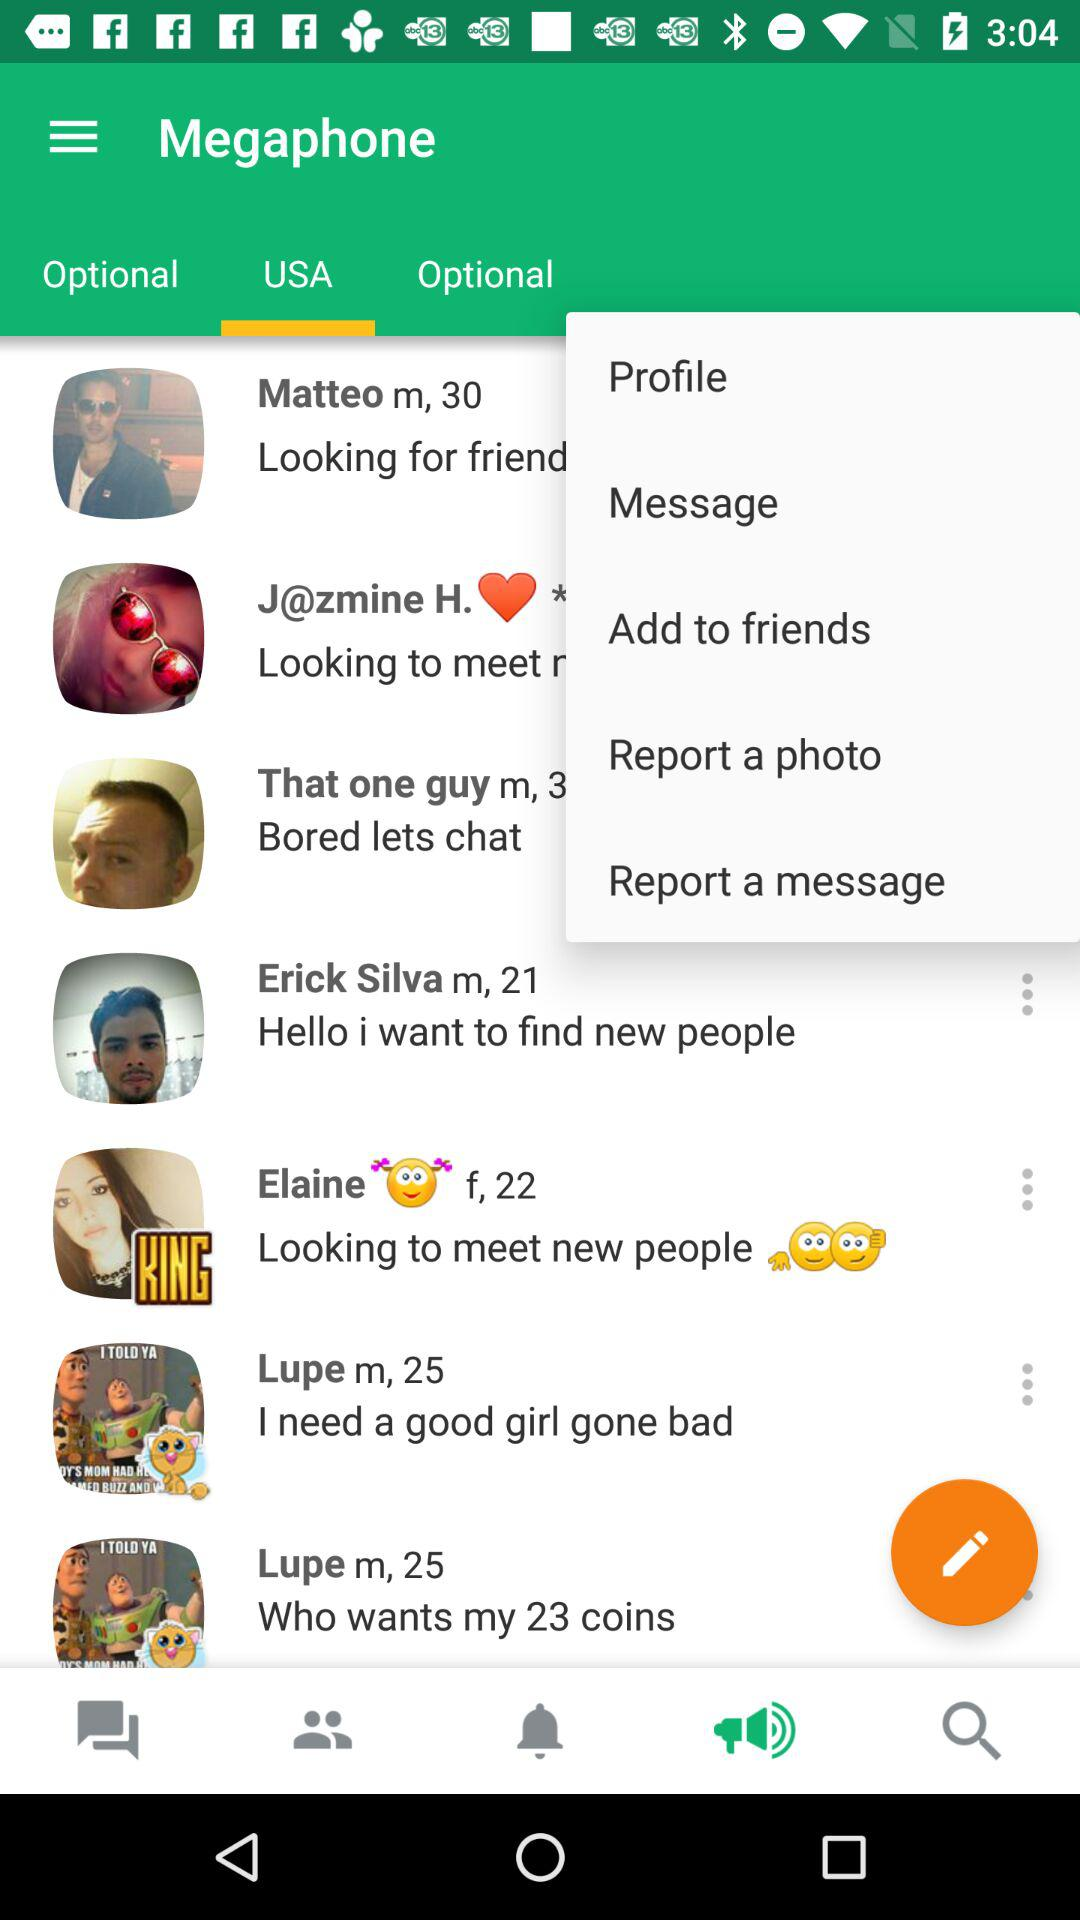Which tab is selected? The selected tabs are "USA" and "Megaphone". 